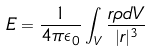<formula> <loc_0><loc_0><loc_500><loc_500>E = \frac { 1 } { 4 \pi \epsilon _ { 0 } } \int _ { V } \frac { r \rho d V } { | r | ^ { 3 } }</formula> 